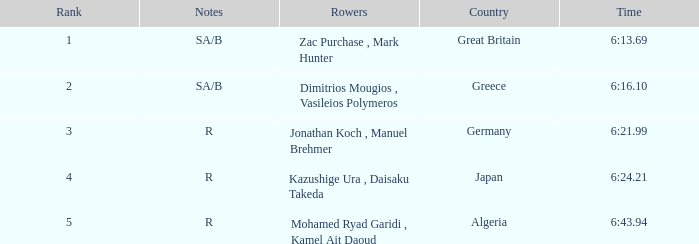What's the time of Rank 3? 6:21.99. Write the full table. {'header': ['Rank', 'Notes', 'Rowers', 'Country', 'Time'], 'rows': [['1', 'SA/B', 'Zac Purchase , Mark Hunter', 'Great Britain', '6:13.69'], ['2', 'SA/B', 'Dimitrios Mougios , Vasileios Polymeros', 'Greece', '6:16.10'], ['3', 'R', 'Jonathan Koch , Manuel Brehmer', 'Germany', '6:21.99'], ['4', 'R', 'Kazushige Ura , Daisaku Takeda', 'Japan', '6:24.21'], ['5', 'R', 'Mohamed Ryad Garidi , Kamel Ait Daoud', 'Algeria', '6:43.94']]} 